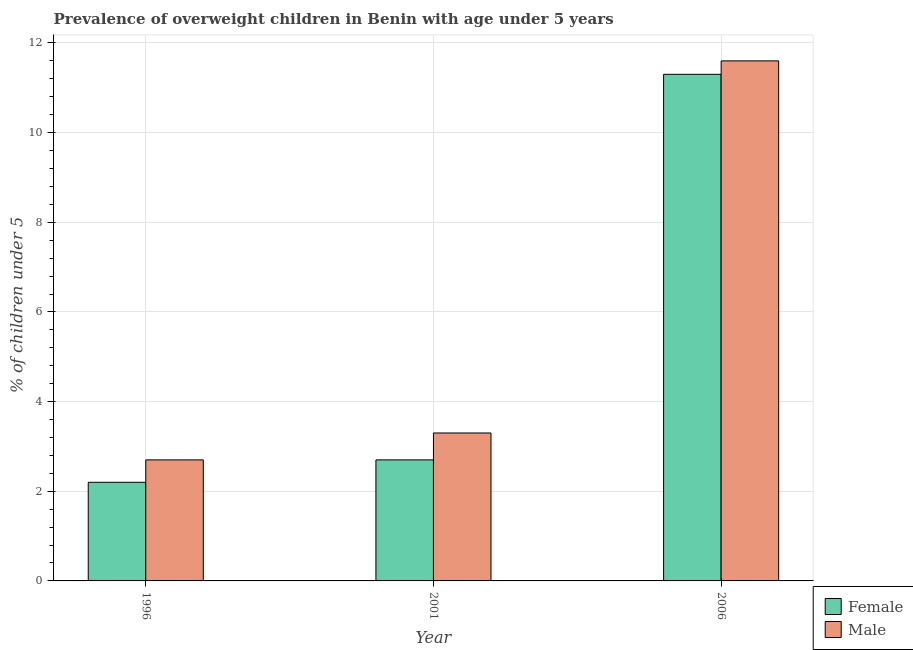How many different coloured bars are there?
Ensure brevity in your answer.  2. How many groups of bars are there?
Your answer should be compact. 3. Are the number of bars on each tick of the X-axis equal?
Give a very brief answer. Yes. How many bars are there on the 3rd tick from the left?
Offer a very short reply. 2. What is the label of the 3rd group of bars from the left?
Provide a succinct answer. 2006. What is the percentage of obese male children in 2001?
Provide a short and direct response. 3.3. Across all years, what is the maximum percentage of obese female children?
Your answer should be compact. 11.3. Across all years, what is the minimum percentage of obese female children?
Your answer should be very brief. 2.2. In which year was the percentage of obese male children maximum?
Provide a short and direct response. 2006. What is the total percentage of obese female children in the graph?
Keep it short and to the point. 16.2. What is the difference between the percentage of obese male children in 2001 and that in 2006?
Your response must be concise. -8.3. What is the difference between the percentage of obese female children in 2001 and the percentage of obese male children in 2006?
Provide a succinct answer. -8.6. What is the average percentage of obese male children per year?
Ensure brevity in your answer.  5.87. In how many years, is the percentage of obese male children greater than 2 %?
Your answer should be very brief. 3. What is the ratio of the percentage of obese female children in 1996 to that in 2006?
Provide a short and direct response. 0.19. Is the percentage of obese male children in 1996 less than that in 2001?
Offer a very short reply. Yes. Is the difference between the percentage of obese male children in 1996 and 2006 greater than the difference between the percentage of obese female children in 1996 and 2006?
Give a very brief answer. No. What is the difference between the highest and the second highest percentage of obese female children?
Your answer should be compact. 8.6. What is the difference between the highest and the lowest percentage of obese female children?
Your answer should be very brief. 9.1. In how many years, is the percentage of obese male children greater than the average percentage of obese male children taken over all years?
Your response must be concise. 1. What does the 1st bar from the right in 1996 represents?
Offer a very short reply. Male. How many bars are there?
Your answer should be very brief. 6. Are all the bars in the graph horizontal?
Ensure brevity in your answer.  No. How many years are there in the graph?
Offer a very short reply. 3. Does the graph contain grids?
Give a very brief answer. Yes. Where does the legend appear in the graph?
Your response must be concise. Bottom right. What is the title of the graph?
Make the answer very short. Prevalence of overweight children in Benin with age under 5 years. Does "Frequency of shipment arrival" appear as one of the legend labels in the graph?
Offer a very short reply. No. What is the label or title of the X-axis?
Your answer should be very brief. Year. What is the label or title of the Y-axis?
Make the answer very short.  % of children under 5. What is the  % of children under 5 of Female in 1996?
Your answer should be very brief. 2.2. What is the  % of children under 5 in Male in 1996?
Provide a short and direct response. 2.7. What is the  % of children under 5 of Female in 2001?
Give a very brief answer. 2.7. What is the  % of children under 5 in Male in 2001?
Provide a succinct answer. 3.3. What is the  % of children under 5 of Female in 2006?
Provide a short and direct response. 11.3. What is the  % of children under 5 of Male in 2006?
Offer a very short reply. 11.6. Across all years, what is the maximum  % of children under 5 of Female?
Ensure brevity in your answer.  11.3. Across all years, what is the maximum  % of children under 5 in Male?
Your answer should be compact. 11.6. Across all years, what is the minimum  % of children under 5 of Female?
Offer a very short reply. 2.2. Across all years, what is the minimum  % of children under 5 of Male?
Make the answer very short. 2.7. What is the difference between the  % of children under 5 in Female in 1996 and that in 2001?
Provide a succinct answer. -0.5. What is the difference between the  % of children under 5 in Female in 1996 and that in 2006?
Your answer should be very brief. -9.1. What is the difference between the  % of children under 5 in Female in 1996 and the  % of children under 5 in Male in 2001?
Offer a terse response. -1.1. What is the difference between the  % of children under 5 in Female in 2001 and the  % of children under 5 in Male in 2006?
Offer a very short reply. -8.9. What is the average  % of children under 5 in Male per year?
Provide a succinct answer. 5.87. In the year 1996, what is the difference between the  % of children under 5 in Female and  % of children under 5 in Male?
Your response must be concise. -0.5. In the year 2006, what is the difference between the  % of children under 5 in Female and  % of children under 5 in Male?
Keep it short and to the point. -0.3. What is the ratio of the  % of children under 5 in Female in 1996 to that in 2001?
Your response must be concise. 0.81. What is the ratio of the  % of children under 5 in Male in 1996 to that in 2001?
Your answer should be compact. 0.82. What is the ratio of the  % of children under 5 in Female in 1996 to that in 2006?
Your answer should be very brief. 0.19. What is the ratio of the  % of children under 5 of Male in 1996 to that in 2006?
Offer a very short reply. 0.23. What is the ratio of the  % of children under 5 of Female in 2001 to that in 2006?
Your answer should be compact. 0.24. What is the ratio of the  % of children under 5 in Male in 2001 to that in 2006?
Offer a very short reply. 0.28. 